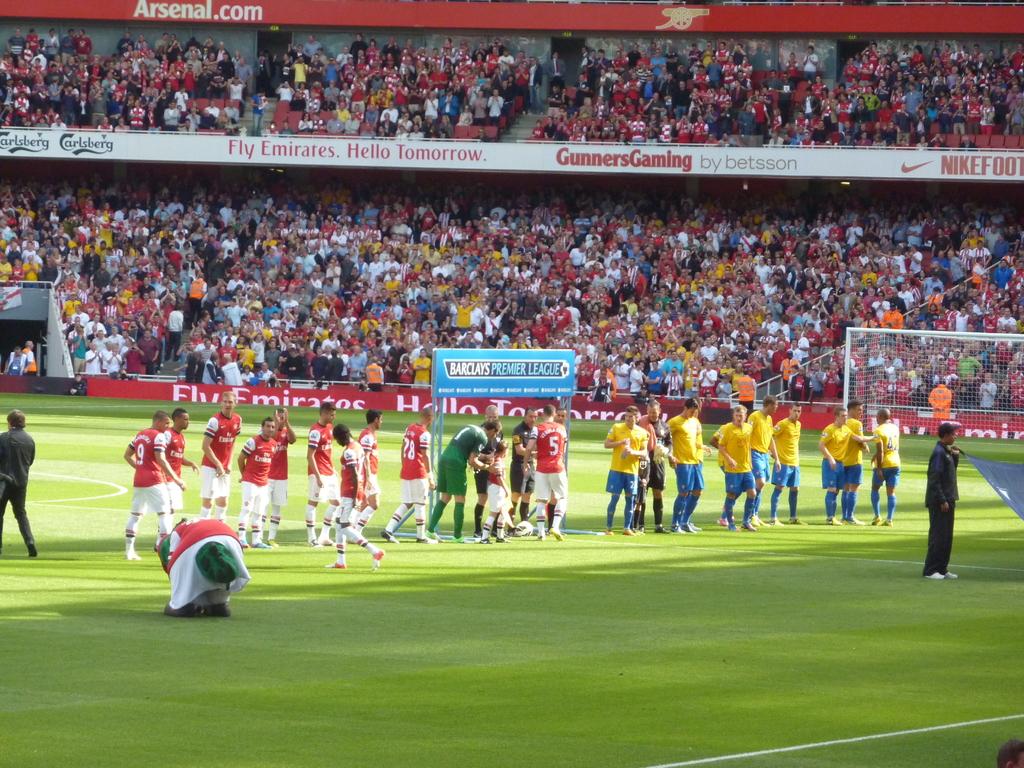Does that sign say hello tomorrow?
Keep it short and to the point. Yes. What is the website at the very top?
Your answer should be very brief. Arsenal.com. 